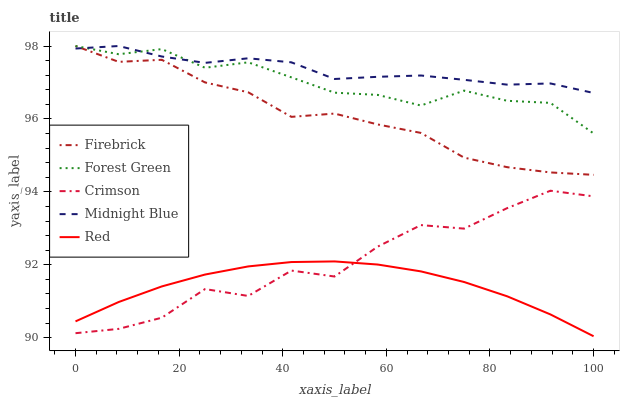Does Red have the minimum area under the curve?
Answer yes or no. Yes. Does Midnight Blue have the maximum area under the curve?
Answer yes or no. Yes. Does Firebrick have the minimum area under the curve?
Answer yes or no. No. Does Firebrick have the maximum area under the curve?
Answer yes or no. No. Is Red the smoothest?
Answer yes or no. Yes. Is Crimson the roughest?
Answer yes or no. Yes. Is Firebrick the smoothest?
Answer yes or no. No. Is Firebrick the roughest?
Answer yes or no. No. Does Firebrick have the lowest value?
Answer yes or no. No. Does Midnight Blue have the highest value?
Answer yes or no. Yes. Does Red have the highest value?
Answer yes or no. No. Is Red less than Firebrick?
Answer yes or no. Yes. Is Midnight Blue greater than Crimson?
Answer yes or no. Yes. Does Midnight Blue intersect Firebrick?
Answer yes or no. Yes. Is Midnight Blue less than Firebrick?
Answer yes or no. No. Is Midnight Blue greater than Firebrick?
Answer yes or no. No. Does Red intersect Firebrick?
Answer yes or no. No. 